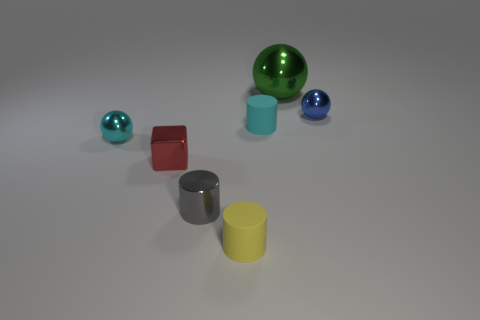Add 2 small blue metal things. How many objects exist? 9 Subtract all cylinders. How many objects are left? 4 Add 2 big green things. How many big green things exist? 3 Subtract 1 red cubes. How many objects are left? 6 Subtract all tiny red things. Subtract all tiny blocks. How many objects are left? 5 Add 4 small cyan matte objects. How many small cyan matte objects are left? 5 